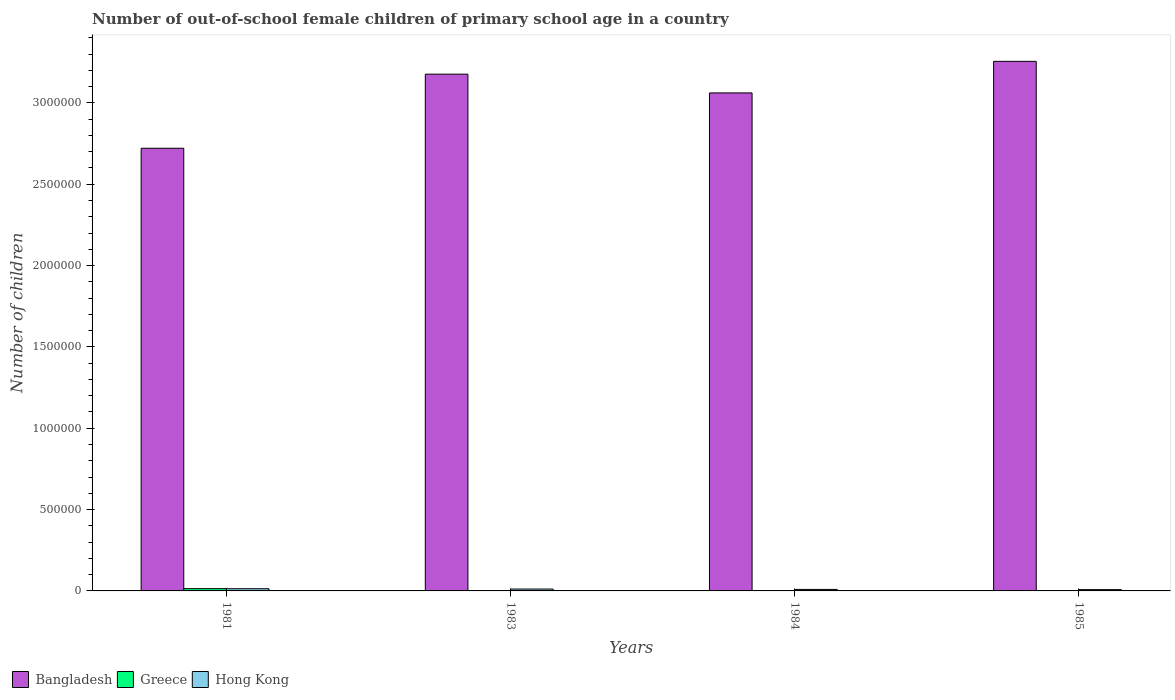How many groups of bars are there?
Ensure brevity in your answer.  4. Are the number of bars per tick equal to the number of legend labels?
Provide a succinct answer. Yes. What is the label of the 4th group of bars from the left?
Ensure brevity in your answer.  1985. What is the number of out-of-school female children in Greece in 1984?
Your answer should be compact. 1011. Across all years, what is the maximum number of out-of-school female children in Hong Kong?
Your response must be concise. 1.36e+04. Across all years, what is the minimum number of out-of-school female children in Bangladesh?
Keep it short and to the point. 2.72e+06. In which year was the number of out-of-school female children in Greece maximum?
Your response must be concise. 1981. In which year was the number of out-of-school female children in Hong Kong minimum?
Make the answer very short. 1985. What is the total number of out-of-school female children in Hong Kong in the graph?
Provide a succinct answer. 4.23e+04. What is the difference between the number of out-of-school female children in Greece in 1981 and that in 1984?
Your response must be concise. 1.30e+04. What is the difference between the number of out-of-school female children in Hong Kong in 1981 and the number of out-of-school female children in Bangladesh in 1983?
Offer a very short reply. -3.16e+06. What is the average number of out-of-school female children in Bangladesh per year?
Provide a short and direct response. 3.05e+06. In the year 1981, what is the difference between the number of out-of-school female children in Hong Kong and number of out-of-school female children in Greece?
Your answer should be compact. -499. In how many years, is the number of out-of-school female children in Hong Kong greater than 2300000?
Provide a succinct answer. 0. What is the ratio of the number of out-of-school female children in Hong Kong in 1983 to that in 1984?
Give a very brief answer. 1.24. Is the number of out-of-school female children in Greece in 1983 less than that in 1985?
Offer a very short reply. No. What is the difference between the highest and the second highest number of out-of-school female children in Greece?
Provide a succinct answer. 1.15e+04. What is the difference between the highest and the lowest number of out-of-school female children in Greece?
Your response must be concise. 1.39e+04. In how many years, is the number of out-of-school female children in Greece greater than the average number of out-of-school female children in Greece taken over all years?
Offer a terse response. 1. What does the 1st bar from the left in 1983 represents?
Ensure brevity in your answer.  Bangladesh. What does the 3rd bar from the right in 1981 represents?
Offer a terse response. Bangladesh. Is it the case that in every year, the sum of the number of out-of-school female children in Bangladesh and number of out-of-school female children in Hong Kong is greater than the number of out-of-school female children in Greece?
Ensure brevity in your answer.  Yes. Are all the bars in the graph horizontal?
Provide a short and direct response. No. How many years are there in the graph?
Your answer should be compact. 4. What is the difference between two consecutive major ticks on the Y-axis?
Offer a very short reply. 5.00e+05. Are the values on the major ticks of Y-axis written in scientific E-notation?
Keep it short and to the point. No. Does the graph contain grids?
Make the answer very short. No. Where does the legend appear in the graph?
Make the answer very short. Bottom left. How many legend labels are there?
Give a very brief answer. 3. How are the legend labels stacked?
Provide a short and direct response. Horizontal. What is the title of the graph?
Give a very brief answer. Number of out-of-school female children of primary school age in a country. Does "Belgium" appear as one of the legend labels in the graph?
Your response must be concise. No. What is the label or title of the Y-axis?
Keep it short and to the point. Number of children. What is the Number of children of Bangladesh in 1981?
Your response must be concise. 2.72e+06. What is the Number of children of Greece in 1981?
Your response must be concise. 1.41e+04. What is the Number of children in Hong Kong in 1981?
Provide a succinct answer. 1.36e+04. What is the Number of children of Bangladesh in 1983?
Keep it short and to the point. 3.18e+06. What is the Number of children of Greece in 1983?
Make the answer very short. 2585. What is the Number of children in Hong Kong in 1983?
Your answer should be compact. 1.15e+04. What is the Number of children of Bangladesh in 1984?
Give a very brief answer. 3.06e+06. What is the Number of children in Greece in 1984?
Provide a succinct answer. 1011. What is the Number of children of Hong Kong in 1984?
Your answer should be very brief. 9307. What is the Number of children in Bangladesh in 1985?
Your response must be concise. 3.26e+06. What is the Number of children in Greece in 1985?
Your answer should be compact. 192. What is the Number of children in Hong Kong in 1985?
Offer a terse response. 7924. Across all years, what is the maximum Number of children of Bangladesh?
Your answer should be compact. 3.26e+06. Across all years, what is the maximum Number of children in Greece?
Keep it short and to the point. 1.41e+04. Across all years, what is the maximum Number of children of Hong Kong?
Your answer should be compact. 1.36e+04. Across all years, what is the minimum Number of children of Bangladesh?
Offer a very short reply. 2.72e+06. Across all years, what is the minimum Number of children of Greece?
Your response must be concise. 192. Across all years, what is the minimum Number of children in Hong Kong?
Offer a terse response. 7924. What is the total Number of children of Bangladesh in the graph?
Make the answer very short. 1.22e+07. What is the total Number of children of Greece in the graph?
Your response must be concise. 1.78e+04. What is the total Number of children in Hong Kong in the graph?
Provide a short and direct response. 4.23e+04. What is the difference between the Number of children in Bangladesh in 1981 and that in 1983?
Your answer should be compact. -4.55e+05. What is the difference between the Number of children of Greece in 1981 and that in 1983?
Provide a succinct answer. 1.15e+04. What is the difference between the Number of children in Hong Kong in 1981 and that in 1983?
Ensure brevity in your answer.  2039. What is the difference between the Number of children of Bangladesh in 1981 and that in 1984?
Give a very brief answer. -3.40e+05. What is the difference between the Number of children of Greece in 1981 and that in 1984?
Your answer should be compact. 1.30e+04. What is the difference between the Number of children of Hong Kong in 1981 and that in 1984?
Your answer should be compact. 4246. What is the difference between the Number of children in Bangladesh in 1981 and that in 1985?
Provide a short and direct response. -5.34e+05. What is the difference between the Number of children in Greece in 1981 and that in 1985?
Ensure brevity in your answer.  1.39e+04. What is the difference between the Number of children in Hong Kong in 1981 and that in 1985?
Your response must be concise. 5629. What is the difference between the Number of children in Bangladesh in 1983 and that in 1984?
Give a very brief answer. 1.15e+05. What is the difference between the Number of children in Greece in 1983 and that in 1984?
Provide a succinct answer. 1574. What is the difference between the Number of children in Hong Kong in 1983 and that in 1984?
Your answer should be very brief. 2207. What is the difference between the Number of children in Bangladesh in 1983 and that in 1985?
Give a very brief answer. -7.88e+04. What is the difference between the Number of children in Greece in 1983 and that in 1985?
Offer a very short reply. 2393. What is the difference between the Number of children in Hong Kong in 1983 and that in 1985?
Provide a succinct answer. 3590. What is the difference between the Number of children of Bangladesh in 1984 and that in 1985?
Provide a succinct answer. -1.94e+05. What is the difference between the Number of children of Greece in 1984 and that in 1985?
Your response must be concise. 819. What is the difference between the Number of children in Hong Kong in 1984 and that in 1985?
Your answer should be very brief. 1383. What is the difference between the Number of children of Bangladesh in 1981 and the Number of children of Greece in 1983?
Keep it short and to the point. 2.72e+06. What is the difference between the Number of children in Bangladesh in 1981 and the Number of children in Hong Kong in 1983?
Make the answer very short. 2.71e+06. What is the difference between the Number of children in Greece in 1981 and the Number of children in Hong Kong in 1983?
Offer a very short reply. 2538. What is the difference between the Number of children in Bangladesh in 1981 and the Number of children in Greece in 1984?
Ensure brevity in your answer.  2.72e+06. What is the difference between the Number of children in Bangladesh in 1981 and the Number of children in Hong Kong in 1984?
Offer a very short reply. 2.71e+06. What is the difference between the Number of children in Greece in 1981 and the Number of children in Hong Kong in 1984?
Provide a succinct answer. 4745. What is the difference between the Number of children of Bangladesh in 1981 and the Number of children of Greece in 1985?
Offer a very short reply. 2.72e+06. What is the difference between the Number of children in Bangladesh in 1981 and the Number of children in Hong Kong in 1985?
Your response must be concise. 2.71e+06. What is the difference between the Number of children of Greece in 1981 and the Number of children of Hong Kong in 1985?
Your answer should be compact. 6128. What is the difference between the Number of children in Bangladesh in 1983 and the Number of children in Greece in 1984?
Keep it short and to the point. 3.18e+06. What is the difference between the Number of children of Bangladesh in 1983 and the Number of children of Hong Kong in 1984?
Your answer should be compact. 3.17e+06. What is the difference between the Number of children in Greece in 1983 and the Number of children in Hong Kong in 1984?
Keep it short and to the point. -6722. What is the difference between the Number of children in Bangladesh in 1983 and the Number of children in Greece in 1985?
Your answer should be compact. 3.18e+06. What is the difference between the Number of children in Bangladesh in 1983 and the Number of children in Hong Kong in 1985?
Your answer should be very brief. 3.17e+06. What is the difference between the Number of children in Greece in 1983 and the Number of children in Hong Kong in 1985?
Offer a terse response. -5339. What is the difference between the Number of children of Bangladesh in 1984 and the Number of children of Greece in 1985?
Your response must be concise. 3.06e+06. What is the difference between the Number of children in Bangladesh in 1984 and the Number of children in Hong Kong in 1985?
Provide a short and direct response. 3.05e+06. What is the difference between the Number of children of Greece in 1984 and the Number of children of Hong Kong in 1985?
Give a very brief answer. -6913. What is the average Number of children of Bangladesh per year?
Provide a short and direct response. 3.05e+06. What is the average Number of children of Greece per year?
Offer a very short reply. 4460. What is the average Number of children in Hong Kong per year?
Give a very brief answer. 1.06e+04. In the year 1981, what is the difference between the Number of children of Bangladesh and Number of children of Greece?
Keep it short and to the point. 2.71e+06. In the year 1981, what is the difference between the Number of children in Bangladesh and Number of children in Hong Kong?
Offer a very short reply. 2.71e+06. In the year 1981, what is the difference between the Number of children in Greece and Number of children in Hong Kong?
Keep it short and to the point. 499. In the year 1983, what is the difference between the Number of children in Bangladesh and Number of children in Greece?
Offer a very short reply. 3.17e+06. In the year 1983, what is the difference between the Number of children of Bangladesh and Number of children of Hong Kong?
Provide a succinct answer. 3.16e+06. In the year 1983, what is the difference between the Number of children of Greece and Number of children of Hong Kong?
Keep it short and to the point. -8929. In the year 1984, what is the difference between the Number of children in Bangladesh and Number of children in Greece?
Your response must be concise. 3.06e+06. In the year 1984, what is the difference between the Number of children of Bangladesh and Number of children of Hong Kong?
Ensure brevity in your answer.  3.05e+06. In the year 1984, what is the difference between the Number of children in Greece and Number of children in Hong Kong?
Give a very brief answer. -8296. In the year 1985, what is the difference between the Number of children of Bangladesh and Number of children of Greece?
Offer a very short reply. 3.26e+06. In the year 1985, what is the difference between the Number of children of Bangladesh and Number of children of Hong Kong?
Offer a terse response. 3.25e+06. In the year 1985, what is the difference between the Number of children of Greece and Number of children of Hong Kong?
Give a very brief answer. -7732. What is the ratio of the Number of children in Bangladesh in 1981 to that in 1983?
Offer a terse response. 0.86. What is the ratio of the Number of children of Greece in 1981 to that in 1983?
Your answer should be compact. 5.44. What is the ratio of the Number of children of Hong Kong in 1981 to that in 1983?
Provide a succinct answer. 1.18. What is the ratio of the Number of children of Bangladesh in 1981 to that in 1984?
Offer a terse response. 0.89. What is the ratio of the Number of children in Greece in 1981 to that in 1984?
Provide a short and direct response. 13.9. What is the ratio of the Number of children in Hong Kong in 1981 to that in 1984?
Your response must be concise. 1.46. What is the ratio of the Number of children of Bangladesh in 1981 to that in 1985?
Offer a very short reply. 0.84. What is the ratio of the Number of children in Greece in 1981 to that in 1985?
Ensure brevity in your answer.  73.19. What is the ratio of the Number of children of Hong Kong in 1981 to that in 1985?
Your answer should be compact. 1.71. What is the ratio of the Number of children of Bangladesh in 1983 to that in 1984?
Provide a short and direct response. 1.04. What is the ratio of the Number of children of Greece in 1983 to that in 1984?
Offer a terse response. 2.56. What is the ratio of the Number of children in Hong Kong in 1983 to that in 1984?
Offer a terse response. 1.24. What is the ratio of the Number of children of Bangladesh in 1983 to that in 1985?
Offer a very short reply. 0.98. What is the ratio of the Number of children of Greece in 1983 to that in 1985?
Your answer should be very brief. 13.46. What is the ratio of the Number of children in Hong Kong in 1983 to that in 1985?
Keep it short and to the point. 1.45. What is the ratio of the Number of children of Bangladesh in 1984 to that in 1985?
Your answer should be very brief. 0.94. What is the ratio of the Number of children in Greece in 1984 to that in 1985?
Provide a succinct answer. 5.27. What is the ratio of the Number of children in Hong Kong in 1984 to that in 1985?
Keep it short and to the point. 1.17. What is the difference between the highest and the second highest Number of children of Bangladesh?
Your answer should be very brief. 7.88e+04. What is the difference between the highest and the second highest Number of children of Greece?
Keep it short and to the point. 1.15e+04. What is the difference between the highest and the second highest Number of children in Hong Kong?
Your answer should be very brief. 2039. What is the difference between the highest and the lowest Number of children in Bangladesh?
Keep it short and to the point. 5.34e+05. What is the difference between the highest and the lowest Number of children of Greece?
Your response must be concise. 1.39e+04. What is the difference between the highest and the lowest Number of children in Hong Kong?
Your answer should be compact. 5629. 